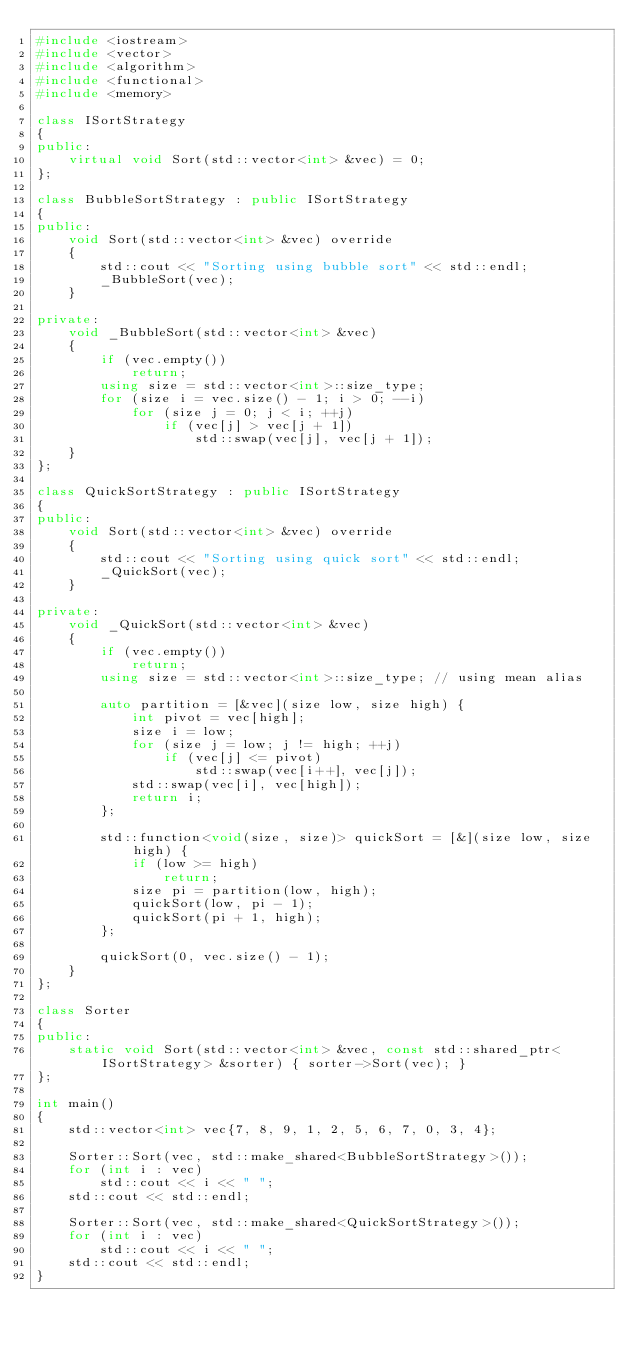Convert code to text. <code><loc_0><loc_0><loc_500><loc_500><_C++_>#include <iostream>
#include <vector>
#include <algorithm>
#include <functional>
#include <memory>

class ISortStrategy
{
public:
    virtual void Sort(std::vector<int> &vec) = 0;
};

class BubbleSortStrategy : public ISortStrategy
{
public:
    void Sort(std::vector<int> &vec) override
    {
        std::cout << "Sorting using bubble sort" << std::endl;
        _BubbleSort(vec);
    }

private:
    void _BubbleSort(std::vector<int> &vec)
    {
        if (vec.empty())
            return;
        using size = std::vector<int>::size_type;
        for (size i = vec.size() - 1; i > 0; --i)
            for (size j = 0; j < i; ++j)
                if (vec[j] > vec[j + 1])
                    std::swap(vec[j], vec[j + 1]);
    }
};

class QuickSortStrategy : public ISortStrategy
{
public:
    void Sort(std::vector<int> &vec) override
    {
        std::cout << "Sorting using quick sort" << std::endl;
        _QuickSort(vec);
    }

private:
    void _QuickSort(std::vector<int> &vec)
    {
        if (vec.empty())
            return;
        using size = std::vector<int>::size_type; // using mean alias

        auto partition = [&vec](size low, size high) {
            int pivot = vec[high];
            size i = low;
            for (size j = low; j != high; ++j)
                if (vec[j] <= pivot)
                    std::swap(vec[i++], vec[j]);
            std::swap(vec[i], vec[high]);
            return i;
        };

        std::function<void(size, size)> quickSort = [&](size low, size high) {
            if (low >= high)
                return;
            size pi = partition(low, high);
            quickSort(low, pi - 1);
            quickSort(pi + 1, high);
        };

        quickSort(0, vec.size() - 1);
    }
};

class Sorter
{
public:
    static void Sort(std::vector<int> &vec, const std::shared_ptr<ISortStrategy> &sorter) { sorter->Sort(vec); }
};

int main()
{
    std::vector<int> vec{7, 8, 9, 1, 2, 5, 6, 7, 0, 3, 4};

    Sorter::Sort(vec, std::make_shared<BubbleSortStrategy>());
    for (int i : vec)
        std::cout << i << " ";
    std::cout << std::endl;

    Sorter::Sort(vec, std::make_shared<QuickSortStrategy>());
    for (int i : vec)
        std::cout << i << " ";
    std::cout << std::endl;
}
</code> 